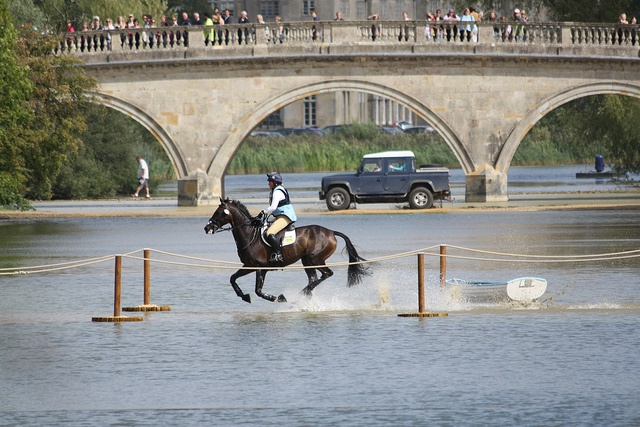Describe the objects in this image and their specific colors. I can see horse in olive, black, gray, and darkgray tones, truck in olive, gray, black, darkblue, and darkgray tones, boat in olive, darkgray, lightgray, and gray tones, people in olive, black, white, gray, and beige tones, and people in olive, darkgray, gray, tan, and black tones in this image. 